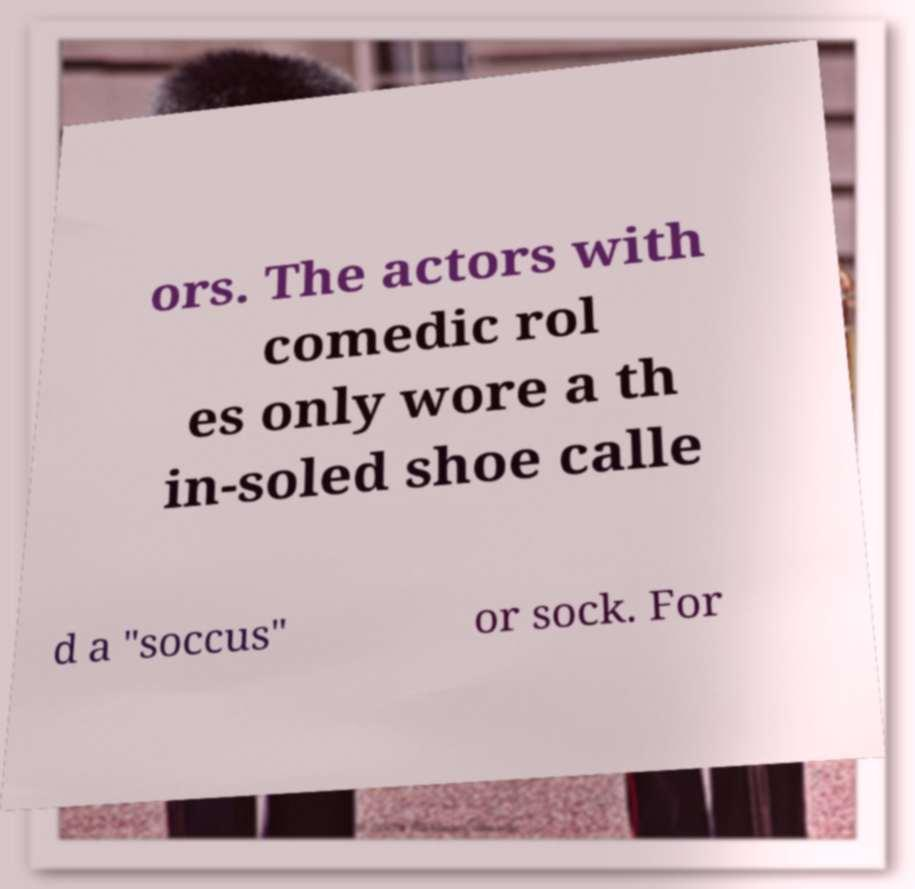Can you read and provide the text displayed in the image?This photo seems to have some interesting text. Can you extract and type it out for me? ors. The actors with comedic rol es only wore a th in-soled shoe calle d a "soccus" or sock. For 